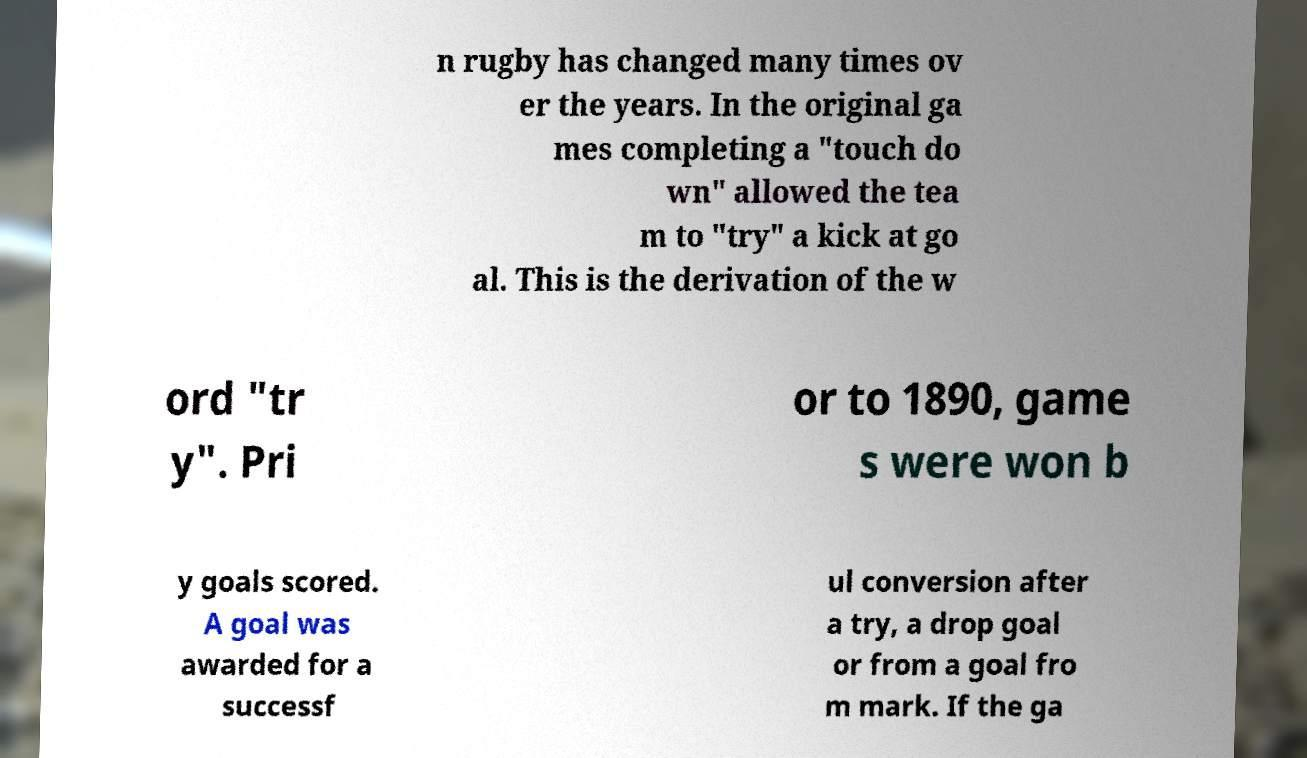Can you read and provide the text displayed in the image?This photo seems to have some interesting text. Can you extract and type it out for me? n rugby has changed many times ov er the years. In the original ga mes completing a "touch do wn" allowed the tea m to "try" a kick at go al. This is the derivation of the w ord "tr y". Pri or to 1890, game s were won b y goals scored. A goal was awarded for a successf ul conversion after a try, a drop goal or from a goal fro m mark. If the ga 